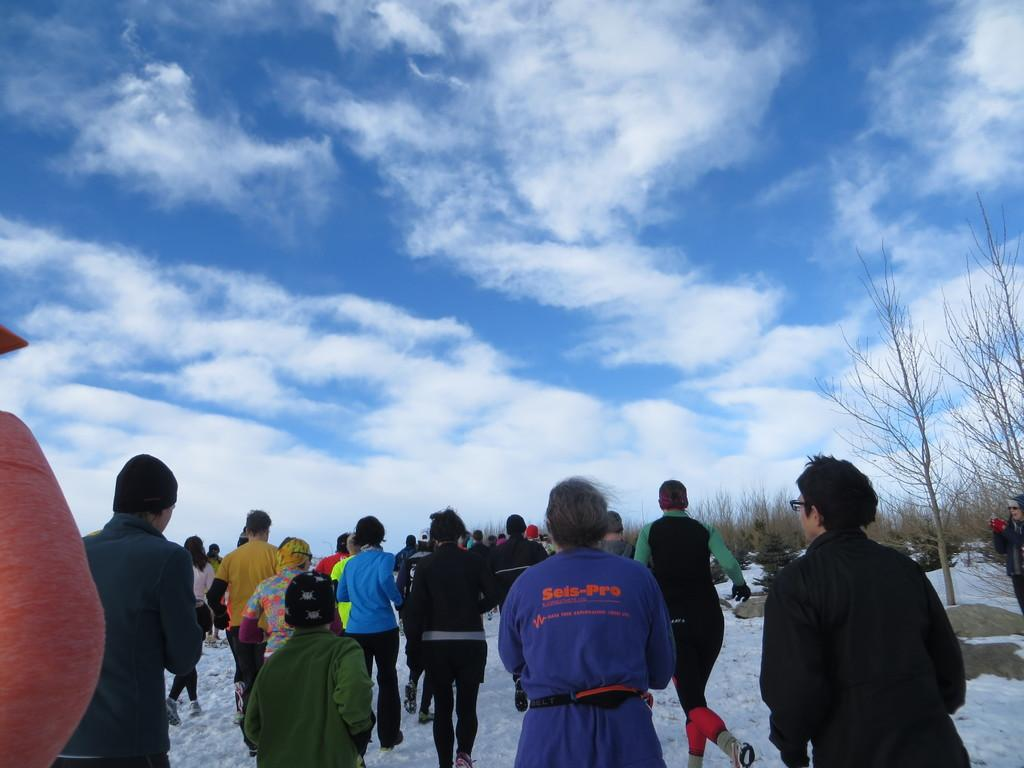What are the people in the image doing? The people in the image are walking on the snow. Can you describe the gender of the people in the image? There are men, women, and children in the image. What is visible in the sky in the background of the image? There are clouds visible in the sky in the background of the image. What type of glue is being used by the children in the image? There is no glue present in the image; the children are walking on the snow. Can you describe the bubble that the men are blowing in the image? There is no bubble present in the image; the men are walking on the snow. 